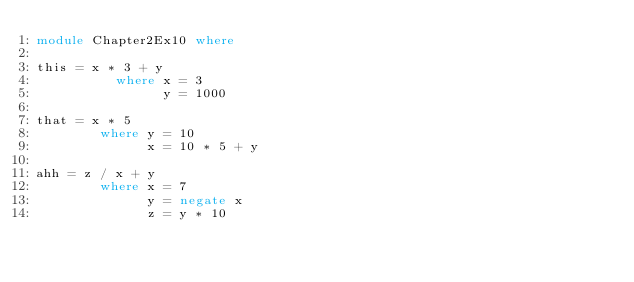Convert code to text. <code><loc_0><loc_0><loc_500><loc_500><_Haskell_>module Chapter2Ex10 where

this = x * 3 + y
          where x = 3
                y = 1000

that = x * 5
        where y = 10
              x = 10 * 5 + y

ahh = z / x + y
        where x = 7
              y = negate x
              z = y * 10
</code> 